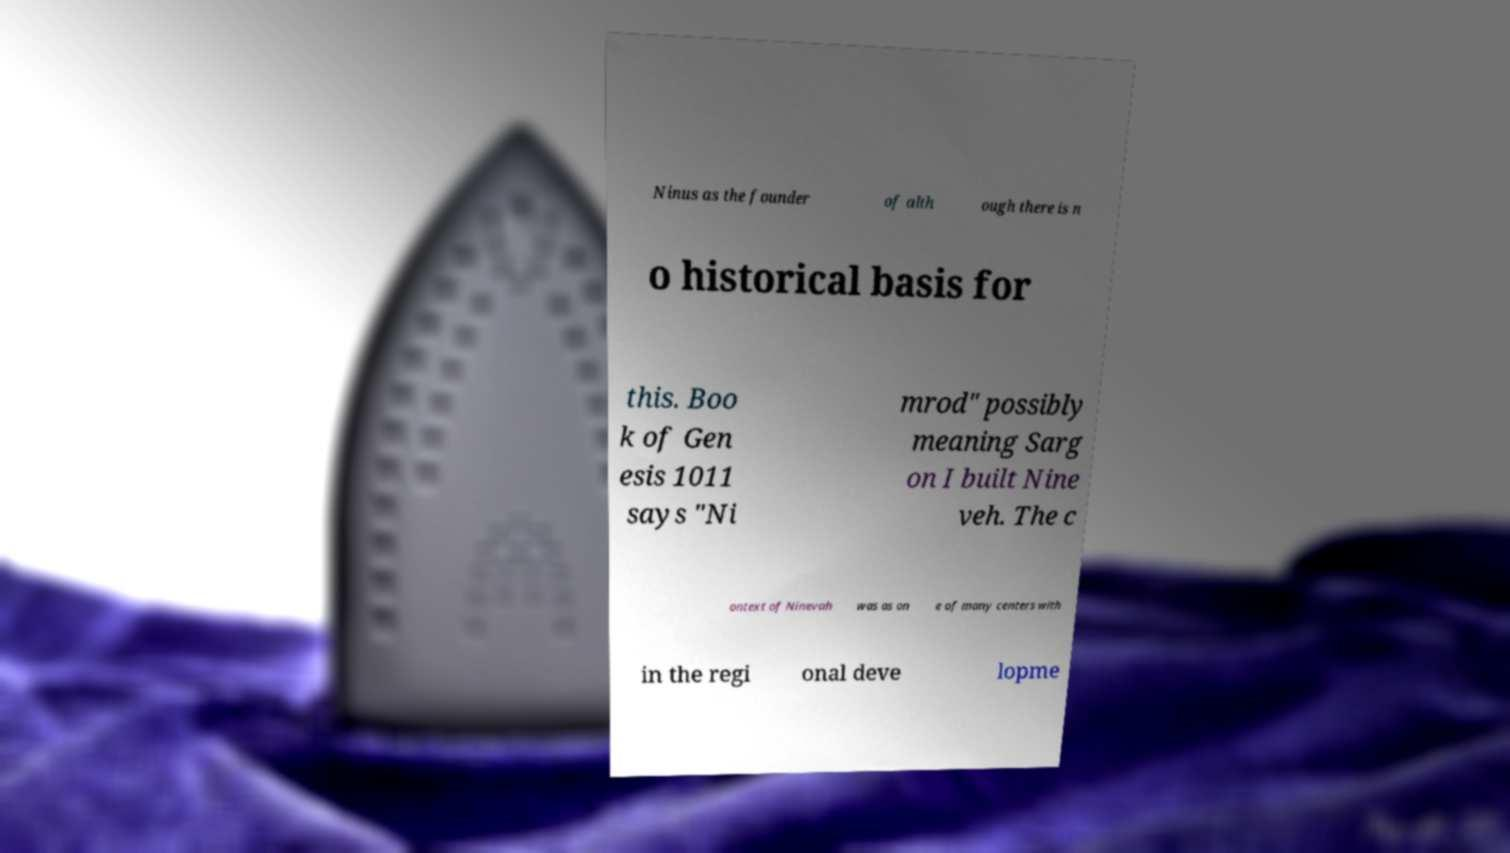Could you extract and type out the text from this image? Ninus as the founder of alth ough there is n o historical basis for this. Boo k of Gen esis 1011 says "Ni mrod" possibly meaning Sarg on I built Nine veh. The c ontext of Ninevah was as on e of many centers with in the regi onal deve lopme 